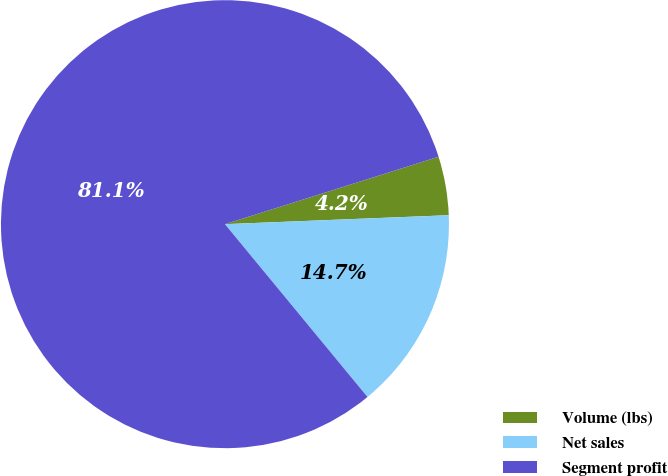Convert chart. <chart><loc_0><loc_0><loc_500><loc_500><pie_chart><fcel>Volume (lbs)<fcel>Net sales<fcel>Segment profit<nl><fcel>4.23%<fcel>14.66%<fcel>81.11%<nl></chart> 